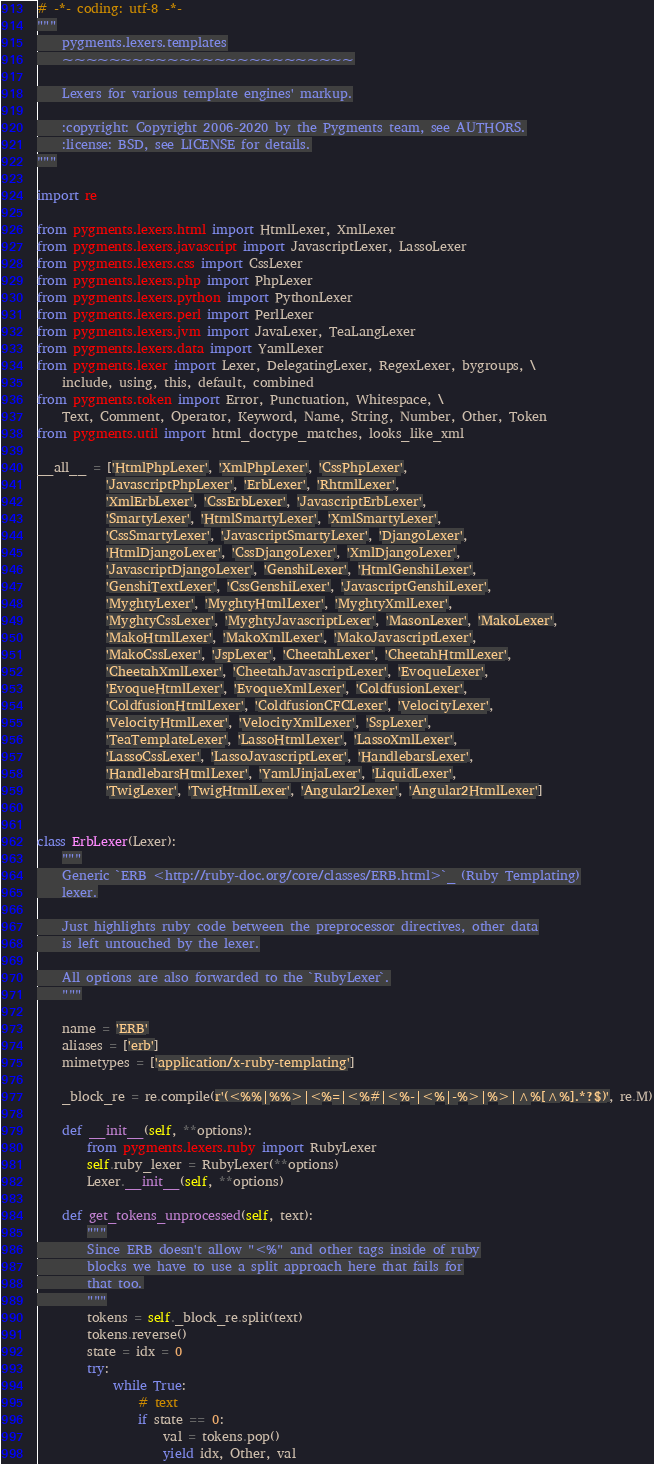Convert code to text. <code><loc_0><loc_0><loc_500><loc_500><_Python_># -*- coding: utf-8 -*-
"""
    pygments.lexers.templates
    ~~~~~~~~~~~~~~~~~~~~~~~~~

    Lexers for various template engines' markup.

    :copyright: Copyright 2006-2020 by the Pygments team, see AUTHORS.
    :license: BSD, see LICENSE for details.
"""

import re

from pygments.lexers.html import HtmlLexer, XmlLexer
from pygments.lexers.javascript import JavascriptLexer, LassoLexer
from pygments.lexers.css import CssLexer
from pygments.lexers.php import PhpLexer
from pygments.lexers.python import PythonLexer
from pygments.lexers.perl import PerlLexer
from pygments.lexers.jvm import JavaLexer, TeaLangLexer
from pygments.lexers.data import YamlLexer
from pygments.lexer import Lexer, DelegatingLexer, RegexLexer, bygroups, \
    include, using, this, default, combined
from pygments.token import Error, Punctuation, Whitespace, \
    Text, Comment, Operator, Keyword, Name, String, Number, Other, Token
from pygments.util import html_doctype_matches, looks_like_xml

__all__ = ['HtmlPhpLexer', 'XmlPhpLexer', 'CssPhpLexer',
           'JavascriptPhpLexer', 'ErbLexer', 'RhtmlLexer',
           'XmlErbLexer', 'CssErbLexer', 'JavascriptErbLexer',
           'SmartyLexer', 'HtmlSmartyLexer', 'XmlSmartyLexer',
           'CssSmartyLexer', 'JavascriptSmartyLexer', 'DjangoLexer',
           'HtmlDjangoLexer', 'CssDjangoLexer', 'XmlDjangoLexer',
           'JavascriptDjangoLexer', 'GenshiLexer', 'HtmlGenshiLexer',
           'GenshiTextLexer', 'CssGenshiLexer', 'JavascriptGenshiLexer',
           'MyghtyLexer', 'MyghtyHtmlLexer', 'MyghtyXmlLexer',
           'MyghtyCssLexer', 'MyghtyJavascriptLexer', 'MasonLexer', 'MakoLexer',
           'MakoHtmlLexer', 'MakoXmlLexer', 'MakoJavascriptLexer',
           'MakoCssLexer', 'JspLexer', 'CheetahLexer', 'CheetahHtmlLexer',
           'CheetahXmlLexer', 'CheetahJavascriptLexer', 'EvoqueLexer',
           'EvoqueHtmlLexer', 'EvoqueXmlLexer', 'ColdfusionLexer',
           'ColdfusionHtmlLexer', 'ColdfusionCFCLexer', 'VelocityLexer',
           'VelocityHtmlLexer', 'VelocityXmlLexer', 'SspLexer',
           'TeaTemplateLexer', 'LassoHtmlLexer', 'LassoXmlLexer',
           'LassoCssLexer', 'LassoJavascriptLexer', 'HandlebarsLexer',
           'HandlebarsHtmlLexer', 'YamlJinjaLexer', 'LiquidLexer',
           'TwigLexer', 'TwigHtmlLexer', 'Angular2Lexer', 'Angular2HtmlLexer']


class ErbLexer(Lexer):
    """
    Generic `ERB <http://ruby-doc.org/core/classes/ERB.html>`_ (Ruby Templating)
    lexer.

    Just highlights ruby code between the preprocessor directives, other data
    is left untouched by the lexer.

    All options are also forwarded to the `RubyLexer`.
    """

    name = 'ERB'
    aliases = ['erb']
    mimetypes = ['application/x-ruby-templating']

    _block_re = re.compile(r'(<%%|%%>|<%=|<%#|<%-|<%|-%>|%>|^%[^%].*?$)', re.M)

    def __init__(self, **options):
        from pygments.lexers.ruby import RubyLexer
        self.ruby_lexer = RubyLexer(**options)
        Lexer.__init__(self, **options)

    def get_tokens_unprocessed(self, text):
        """
        Since ERB doesn't allow "<%" and other tags inside of ruby
        blocks we have to use a split approach here that fails for
        that too.
        """
        tokens = self._block_re.split(text)
        tokens.reverse()
        state = idx = 0
        try:
            while True:
                # text
                if state == 0:
                    val = tokens.pop()
                    yield idx, Other, val</code> 